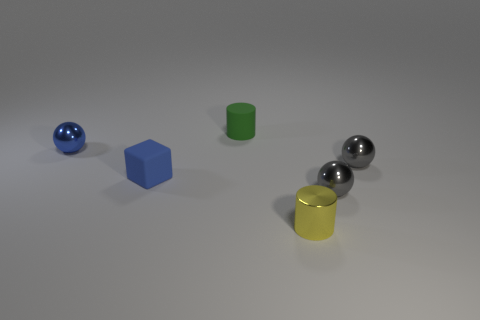Subtract all gray metal balls. How many balls are left? 1 Subtract 1 blocks. How many blocks are left? 0 Subtract all yellow cylinders. How many cylinders are left? 1 Subtract all cubes. How many objects are left? 5 Subtract all brown spheres. Subtract all green cylinders. How many spheres are left? 3 Subtract all blue cylinders. How many gray balls are left? 2 Subtract all shiny spheres. Subtract all tiny blue metal objects. How many objects are left? 2 Add 1 small yellow metal objects. How many small yellow metal objects are left? 2 Add 6 small cyan shiny cylinders. How many small cyan shiny cylinders exist? 6 Add 1 tiny purple matte cylinders. How many objects exist? 7 